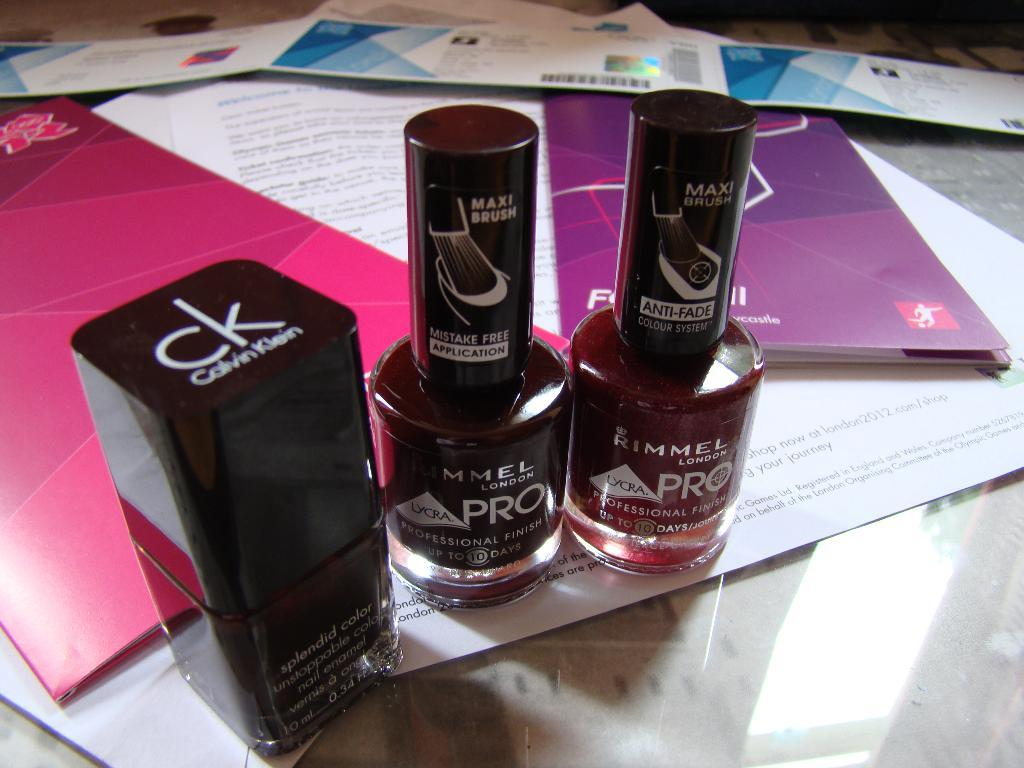<image>
Share a concise interpretation of the image provided. A bottle of CK nailpolish and two bottles of Rimmel polish are on a table. 